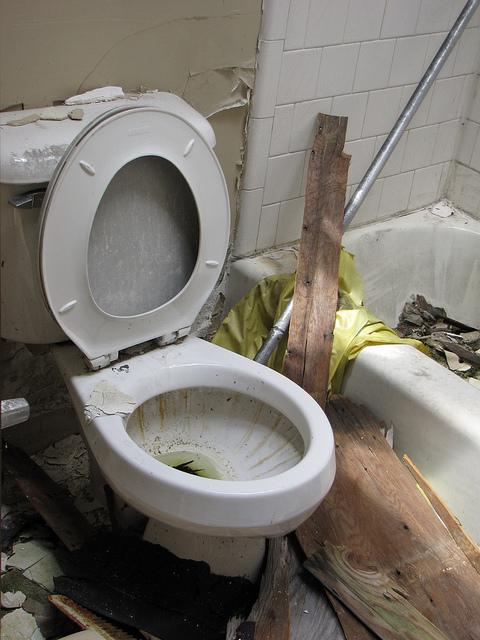Does this room need repair?
Keep it brief. Yes. Will this toilet be replaced?
Quick response, please. Yes. Is this toilet clean?
Be succinct. No. 